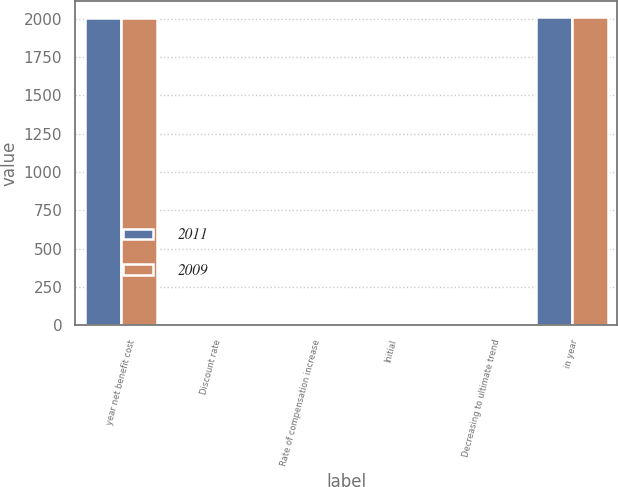Convert chart. <chart><loc_0><loc_0><loc_500><loc_500><stacked_bar_chart><ecel><fcel>year net benefit cost<fcel>Discount rate<fcel>Rate of compensation increase<fcel>Initial<fcel>Decreasing to ultimate trend<fcel>in year<nl><fcel>2011<fcel>2007<fcel>5.86<fcel>3.75<fcel>9<fcel>5<fcel>2011<nl><fcel>2009<fcel>2006<fcel>5.62<fcel>3.75<fcel>8<fcel>5<fcel>2009<nl></chart> 